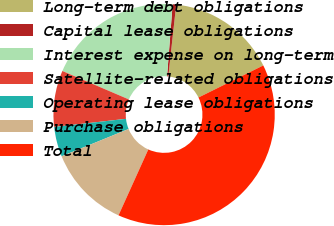<chart> <loc_0><loc_0><loc_500><loc_500><pie_chart><fcel>Long-term debt obligations<fcel>Capital lease obligations<fcel>Interest expense on long-term<fcel>Satellite-related obligations<fcel>Operating lease obligations<fcel>Purchase obligations<fcel>Total<nl><fcel>15.94%<fcel>0.52%<fcel>19.79%<fcel>8.23%<fcel>4.37%<fcel>12.08%<fcel>39.07%<nl></chart> 